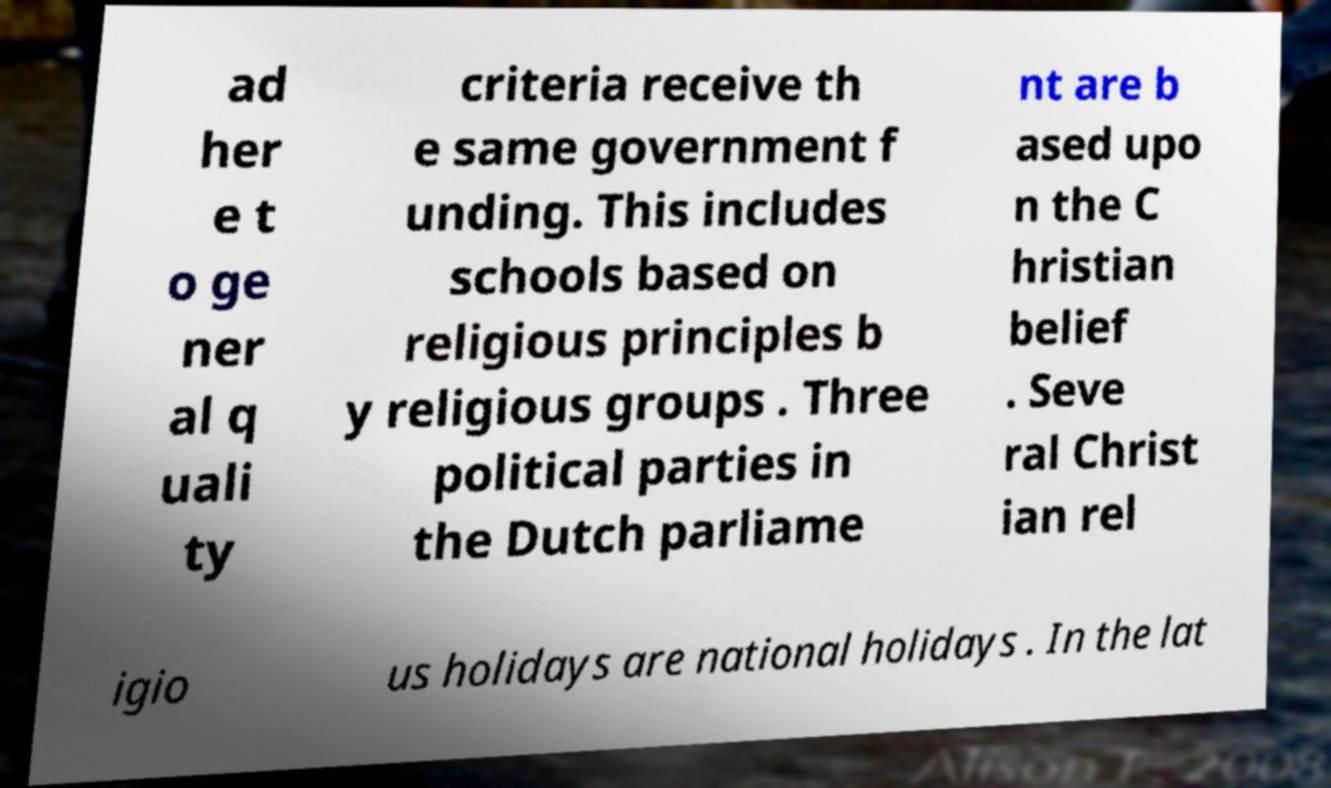Please identify and transcribe the text found in this image. ad her e t o ge ner al q uali ty criteria receive th e same government f unding. This includes schools based on religious principles b y religious groups . Three political parties in the Dutch parliame nt are b ased upo n the C hristian belief . Seve ral Christ ian rel igio us holidays are national holidays . In the lat 